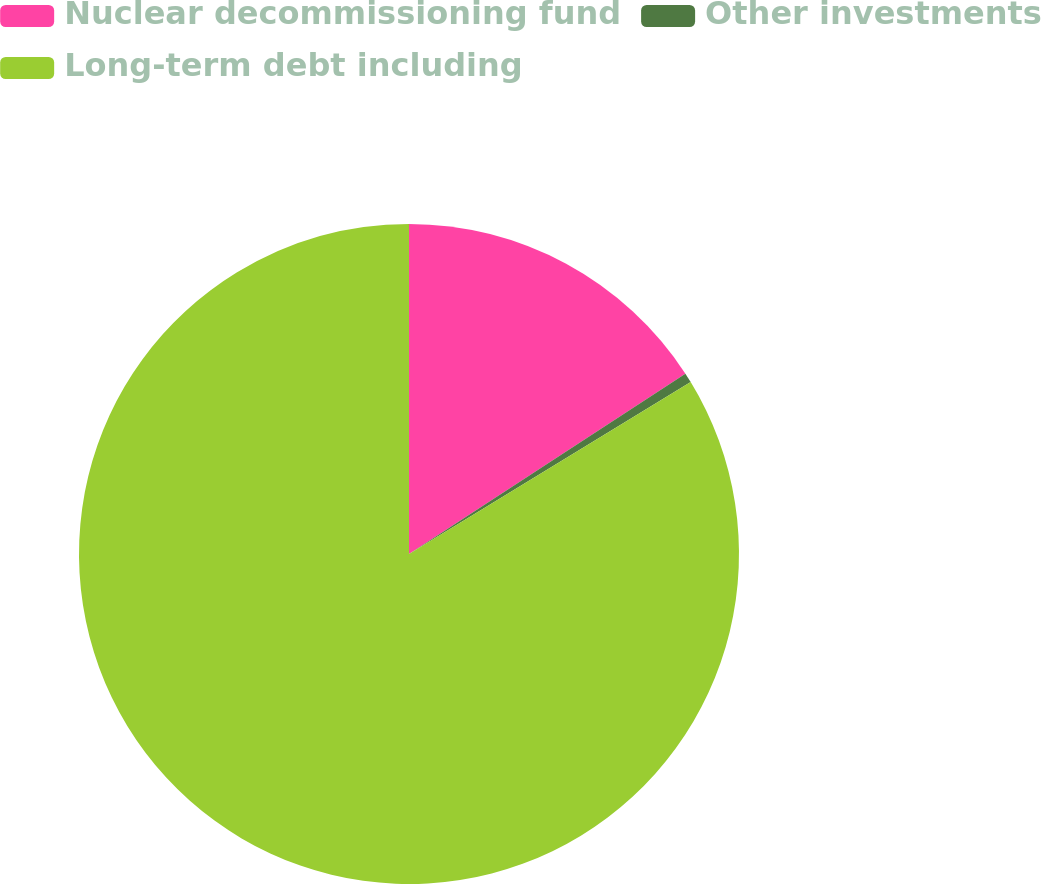<chart> <loc_0><loc_0><loc_500><loc_500><pie_chart><fcel>Nuclear decommissioning fund<fcel>Other investments<fcel>Long-term debt including<nl><fcel>15.8%<fcel>0.48%<fcel>83.72%<nl></chart> 